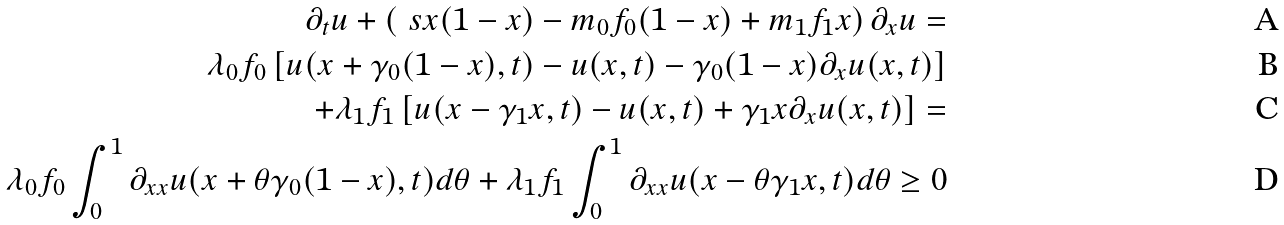<formula> <loc_0><loc_0><loc_500><loc_500>\partial _ { t } u + \left ( \ s x ( 1 - x ) - m _ { 0 } f _ { 0 } ( 1 - x ) + m _ { 1 } f _ { 1 } x \right ) \partial _ { x } u = \\ \lambda _ { 0 } f _ { 0 } \left [ u ( x + \gamma _ { 0 } ( 1 - x ) , t ) - u ( x , t ) - \gamma _ { 0 } ( 1 - x ) \partial _ { x } u ( x , t ) \right ] \\ + \lambda _ { 1 } f _ { 1 } \left [ u ( x - \gamma _ { 1 } x , t ) - u ( x , t ) + \gamma _ { 1 } x \partial _ { x } u ( x , t ) \right ] = \\ \lambda _ { 0 } f _ { 0 } \int _ { 0 } ^ { 1 } \partial _ { x x } u ( x + \theta \gamma _ { 0 } ( 1 - x ) , t ) d \theta + \lambda _ { 1 } f _ { 1 } \int _ { 0 } ^ { 1 } \partial _ { x x } u ( x - \theta \gamma _ { 1 } x , t ) d \theta \geq 0</formula> 